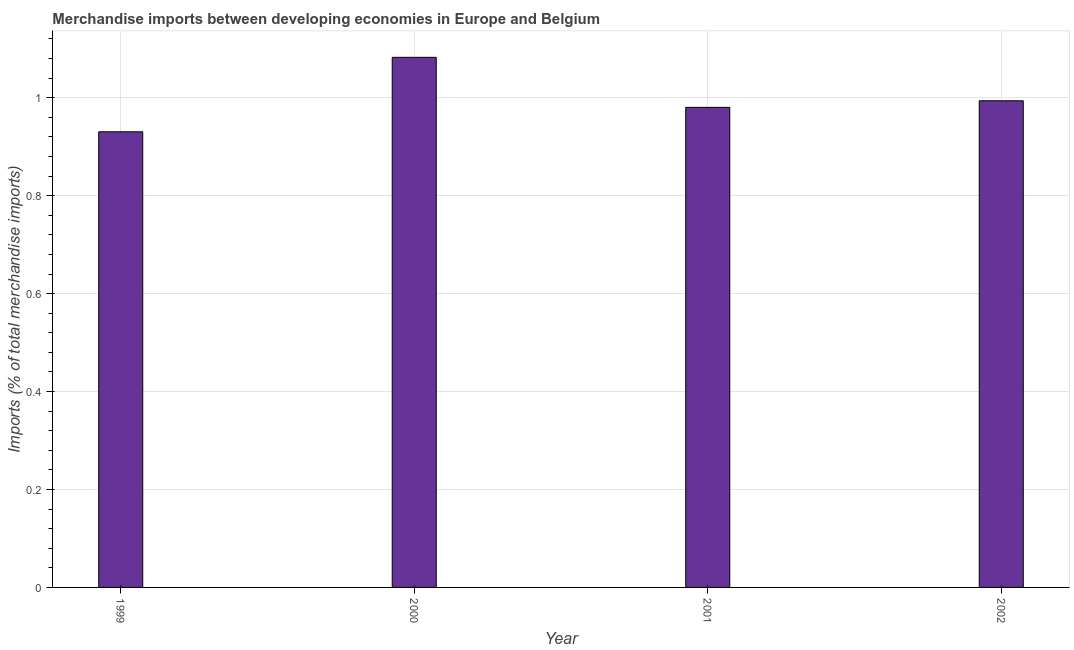Does the graph contain grids?
Provide a short and direct response. Yes. What is the title of the graph?
Provide a short and direct response. Merchandise imports between developing economies in Europe and Belgium. What is the label or title of the Y-axis?
Your answer should be very brief. Imports (% of total merchandise imports). What is the merchandise imports in 1999?
Your answer should be compact. 0.93. Across all years, what is the maximum merchandise imports?
Your answer should be compact. 1.08. Across all years, what is the minimum merchandise imports?
Offer a very short reply. 0.93. In which year was the merchandise imports maximum?
Ensure brevity in your answer.  2000. What is the sum of the merchandise imports?
Provide a short and direct response. 3.99. What is the average merchandise imports per year?
Provide a succinct answer. 1. What is the median merchandise imports?
Keep it short and to the point. 0.99. In how many years, is the merchandise imports greater than 0.52 %?
Provide a succinct answer. 4. What is the ratio of the merchandise imports in 1999 to that in 2001?
Keep it short and to the point. 0.95. Is the merchandise imports in 2001 less than that in 2002?
Make the answer very short. Yes. Is the difference between the merchandise imports in 2000 and 2001 greater than the difference between any two years?
Keep it short and to the point. No. What is the difference between the highest and the second highest merchandise imports?
Provide a short and direct response. 0.09. What is the difference between the highest and the lowest merchandise imports?
Your answer should be compact. 0.15. In how many years, is the merchandise imports greater than the average merchandise imports taken over all years?
Make the answer very short. 1. How many bars are there?
Give a very brief answer. 4. Are all the bars in the graph horizontal?
Make the answer very short. No. How many years are there in the graph?
Your answer should be compact. 4. What is the difference between two consecutive major ticks on the Y-axis?
Your response must be concise. 0.2. Are the values on the major ticks of Y-axis written in scientific E-notation?
Offer a terse response. No. What is the Imports (% of total merchandise imports) of 1999?
Provide a short and direct response. 0.93. What is the Imports (% of total merchandise imports) in 2000?
Give a very brief answer. 1.08. What is the Imports (% of total merchandise imports) of 2001?
Keep it short and to the point. 0.98. What is the Imports (% of total merchandise imports) in 2002?
Make the answer very short. 0.99. What is the difference between the Imports (% of total merchandise imports) in 1999 and 2000?
Provide a succinct answer. -0.15. What is the difference between the Imports (% of total merchandise imports) in 1999 and 2001?
Your answer should be very brief. -0.05. What is the difference between the Imports (% of total merchandise imports) in 1999 and 2002?
Your response must be concise. -0.06. What is the difference between the Imports (% of total merchandise imports) in 2000 and 2001?
Offer a very short reply. 0.1. What is the difference between the Imports (% of total merchandise imports) in 2000 and 2002?
Give a very brief answer. 0.09. What is the difference between the Imports (% of total merchandise imports) in 2001 and 2002?
Provide a succinct answer. -0.01. What is the ratio of the Imports (% of total merchandise imports) in 1999 to that in 2000?
Provide a short and direct response. 0.86. What is the ratio of the Imports (% of total merchandise imports) in 1999 to that in 2001?
Your answer should be compact. 0.95. What is the ratio of the Imports (% of total merchandise imports) in 1999 to that in 2002?
Ensure brevity in your answer.  0.94. What is the ratio of the Imports (% of total merchandise imports) in 2000 to that in 2001?
Ensure brevity in your answer.  1.1. What is the ratio of the Imports (% of total merchandise imports) in 2000 to that in 2002?
Make the answer very short. 1.09. 